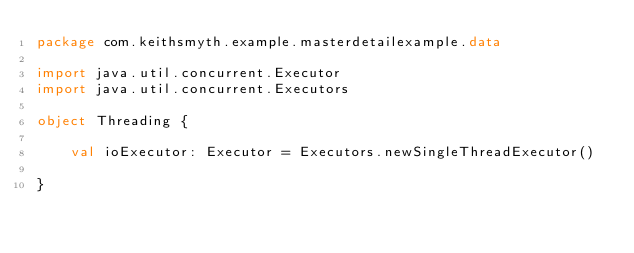<code> <loc_0><loc_0><loc_500><loc_500><_Kotlin_>package com.keithsmyth.example.masterdetailexample.data

import java.util.concurrent.Executor
import java.util.concurrent.Executors

object Threading {

    val ioExecutor: Executor = Executors.newSingleThreadExecutor()

}
</code> 